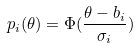<formula> <loc_0><loc_0><loc_500><loc_500>p _ { i } ( \theta ) = \Phi ( \frac { \theta - b _ { i } } { \sigma _ { i } } )</formula> 